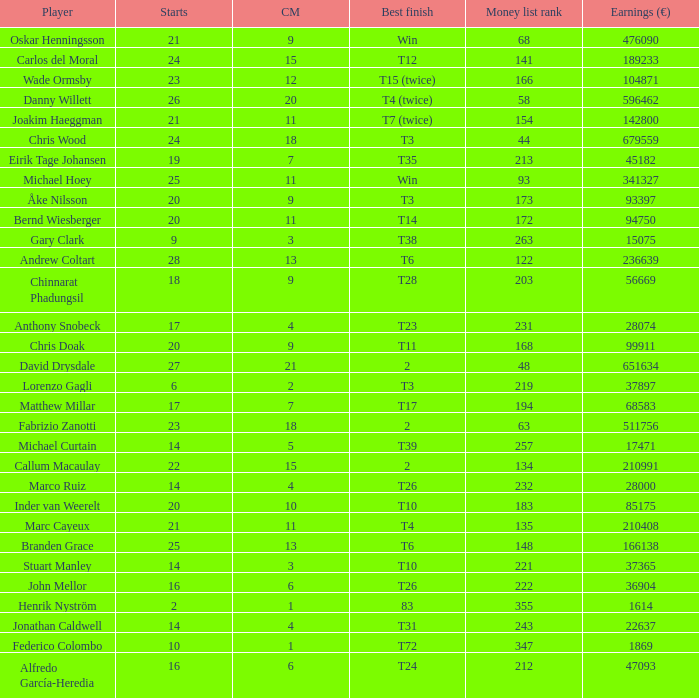How many cuts did the player who earned 210408 Euro make? 11.0. 